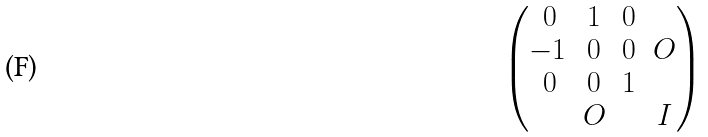Convert formula to latex. <formula><loc_0><loc_0><loc_500><loc_500>\begin{pmatrix} \, 0 & 1 & 0 \\ - 1 & 0 & 0 & O \\ \, 0 & 0 & 1 \\ & O & & I \\ \end{pmatrix}</formula> 